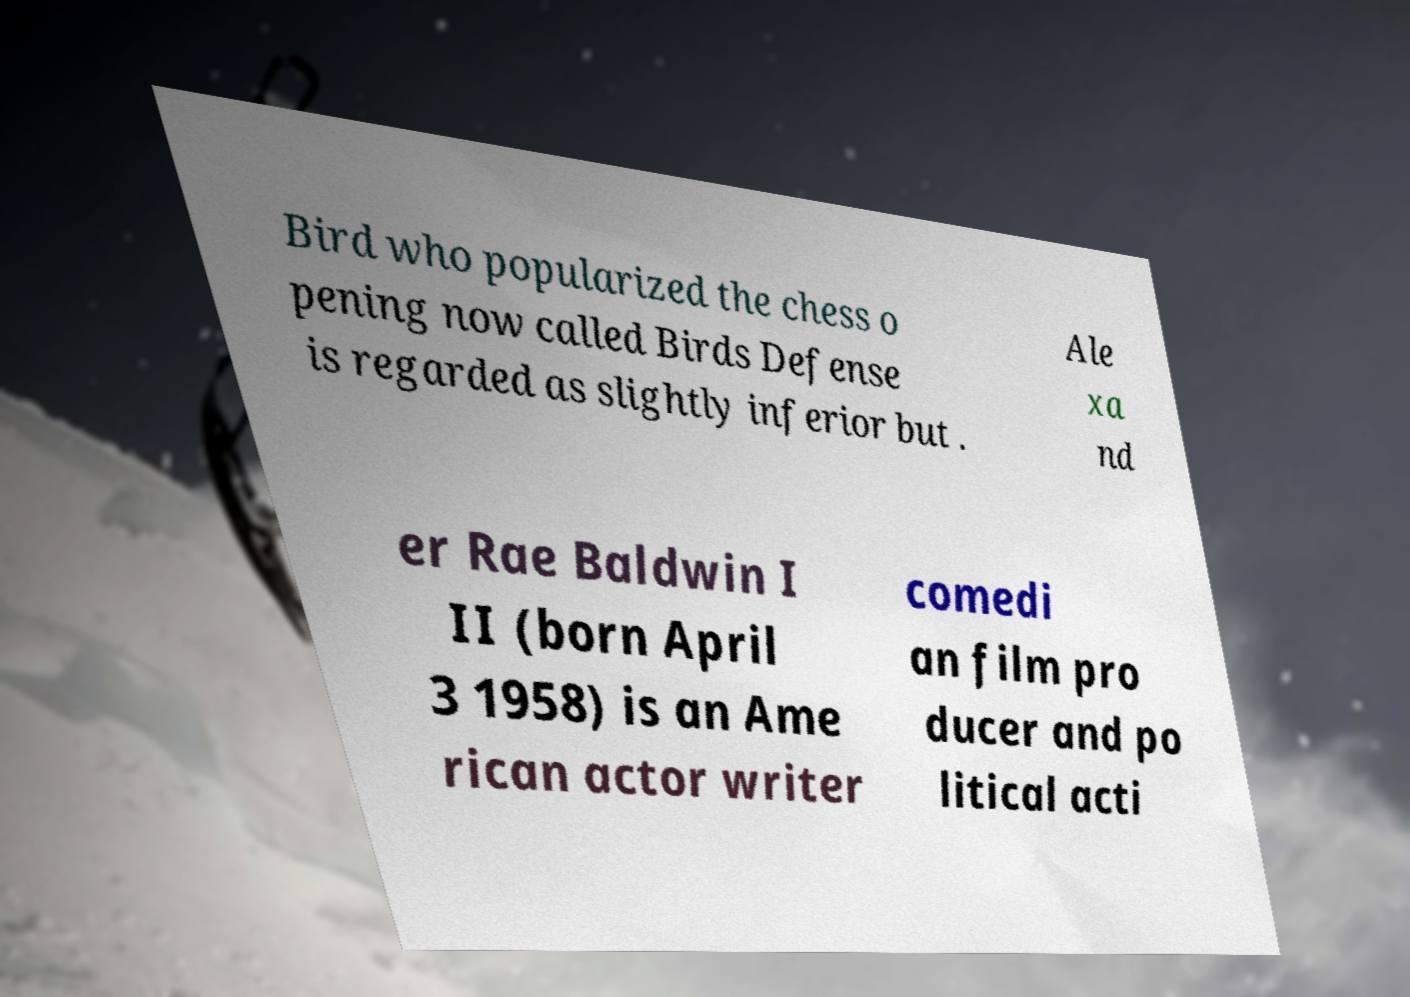What messages or text are displayed in this image? I need them in a readable, typed format. Bird who popularized the chess o pening now called Birds Defense is regarded as slightly inferior but . Ale xa nd er Rae Baldwin I II (born April 3 1958) is an Ame rican actor writer comedi an film pro ducer and po litical acti 